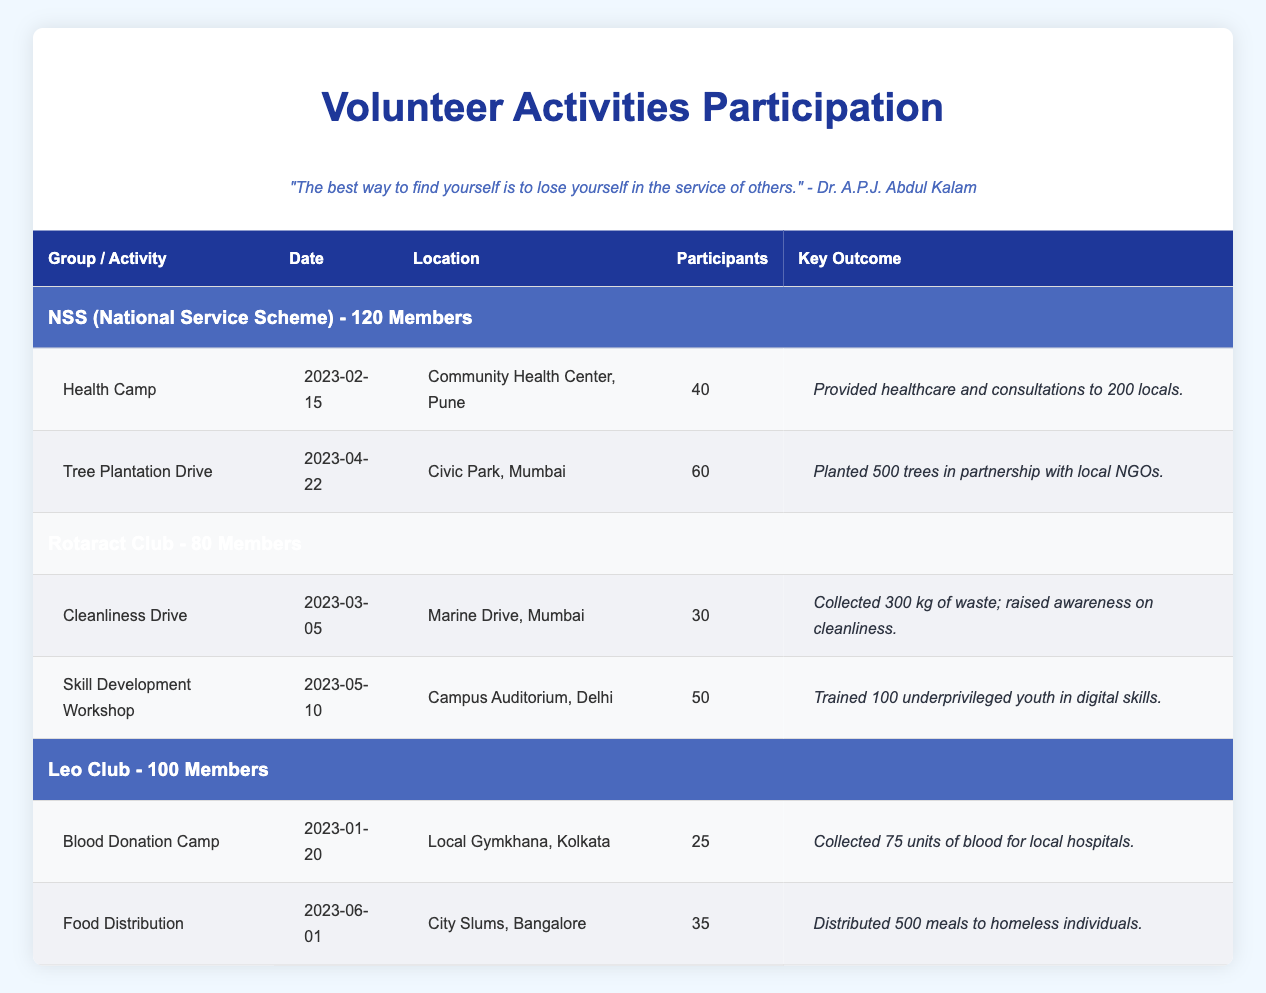What event had the highest number of participants? The highest number of participants can be found by comparing the "Participants" column for each activity. The "Tree Plantation Drive" has 60 participants, which is the highest, while the highest for others are 50, 40, and 35.
Answer: Tree Plantation Drive How many total participants were involved in NSS activities? To find the total participants in NSS activities, add the participants of both events: Health Camp (40) + Tree Plantation Drive (60) = 100.
Answer: 100 Did the Rotaract Club conduct an event for skill development? Looking at the Rotaract Club's activities, the "Skill Development Workshop" is specifically mentioned, confirming they conducted an event focused on skill development.
Answer: Yes What was the key outcome of the Blood Donation Camp? The key outcome is provided in the last column for the Blood Donation Camp event, which states that they collected 75 units of blood for local hospitals.
Answer: Collected 75 units of blood for local hospitals How many more participants did the Tree Plantation Drive have than the Cleanliness Drive? The Tree Plantation Drive had 60 participants and the Cleanliness Drive had 30 participants. To find the difference, subtract: 60 - 30 = 30 more participants in the Tree Plantation Drive.
Answer: 30 What percentage of NSS members participated in the Health Camp? The NSS group has 120 members. To find the percentage of members who participated in the Health Camp (40 participants), use the formula: (40 / 120) * 100 = 33.33%.
Answer: 33.33% Which location had the most volunteer activities taking place? Examining the locations listed, Community Health Center, Pune; Civic Park, Mumbai; Marine Drive, Mumbai; Campus Auditorium, Delhi; Local Gymkhana, Kolkata; and City Slums, Bangalore, it can be seen that Mumbai appears twice (for Tree Plantation Drive and Cleanliness Drive), making it the location with the most volunteer activities.
Answer: Mumbai How many total events were conducted by Leo Club? The total number of events by Leo Club can be found by counting the activities listed: Blood Donation Camp and Food Distribution, totaling 2 events.
Answer: 2 Among all groups, which event had the least number of participants? To find the event with the least participants, compare the participant numbers for all events listed: 40, 60, 30, 50, 25, and 35. The event with the least participants is the Blood Donation Camp with 25 participants.
Answer: Blood Donation Camp 